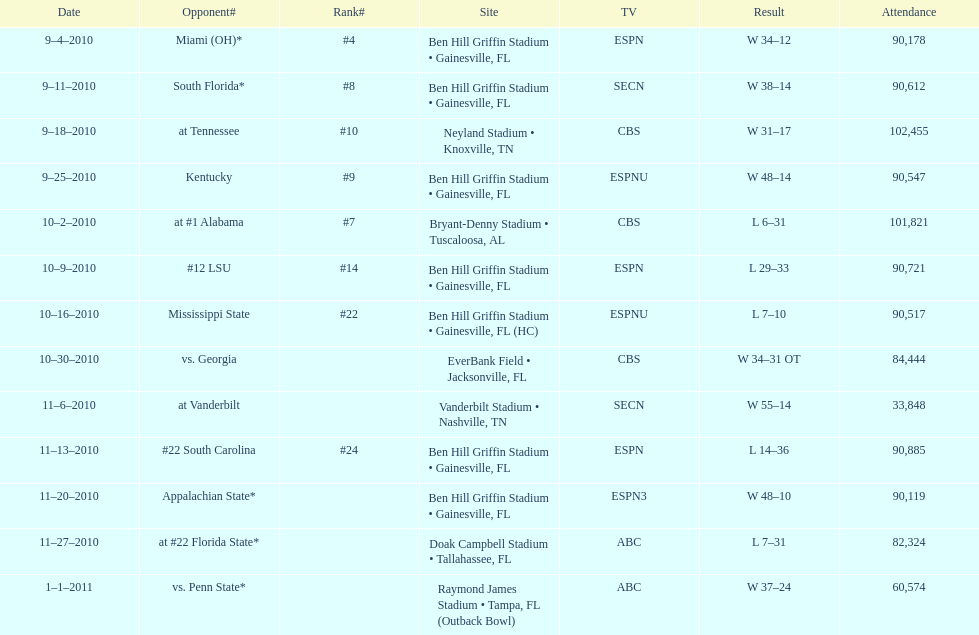Would you mind parsing the complete table? {'header': ['Date', 'Opponent#', 'Rank#', 'Site', 'TV', 'Result', 'Attendance'], 'rows': [['9–4–2010', 'Miami (OH)*', '#4', 'Ben Hill Griffin Stadium • Gainesville, FL', 'ESPN', 'W\xa034–12', '90,178'], ['9–11–2010', 'South Florida*', '#8', 'Ben Hill Griffin Stadium • Gainesville, FL', 'SECN', 'W\xa038–14', '90,612'], ['9–18–2010', 'at\xa0Tennessee', '#10', 'Neyland Stadium • Knoxville, TN', 'CBS', 'W\xa031–17', '102,455'], ['9–25–2010', 'Kentucky', '#9', 'Ben Hill Griffin Stadium • Gainesville, FL', 'ESPNU', 'W\xa048–14', '90,547'], ['10–2–2010', 'at\xa0#1\xa0Alabama', '#7', 'Bryant-Denny Stadium • Tuscaloosa, AL', 'CBS', 'L\xa06–31', '101,821'], ['10–9–2010', '#12\xa0LSU', '#14', 'Ben Hill Griffin Stadium • Gainesville, FL', 'ESPN', 'L\xa029–33', '90,721'], ['10–16–2010', 'Mississippi State', '#22', 'Ben Hill Griffin Stadium • Gainesville, FL (HC)', 'ESPNU', 'L\xa07–10', '90,517'], ['10–30–2010', 'vs.\xa0Georgia', '', 'EverBank Field • Jacksonville, FL', 'CBS', 'W\xa034–31\xa0OT', '84,444'], ['11–6–2010', 'at\xa0Vanderbilt', '', 'Vanderbilt Stadium • Nashville, TN', 'SECN', 'W\xa055–14', '33,848'], ['11–13–2010', '#22\xa0South Carolina', '#24', 'Ben Hill Griffin Stadium • Gainesville, FL', 'ESPN', 'L\xa014–36', '90,885'], ['11–20–2010', 'Appalachian State*', '', 'Ben Hill Griffin Stadium • Gainesville, FL', 'ESPN3', 'W\xa048–10', '90,119'], ['11–27–2010', 'at\xa0#22\xa0Florida State*', '', 'Doak Campbell Stadium • Tallahassee, FL', 'ABC', 'L\xa07–31', '82,324'], ['1–1–2011', 'vs.\xa0Penn State*', '', 'Raymond James Stadium • Tampa, FL (Outback Bowl)', 'ABC', 'W\xa037–24', '60,574']]} In the 2010/2011 season, which tv network had the highest number of game broadcasts? ESPN. 